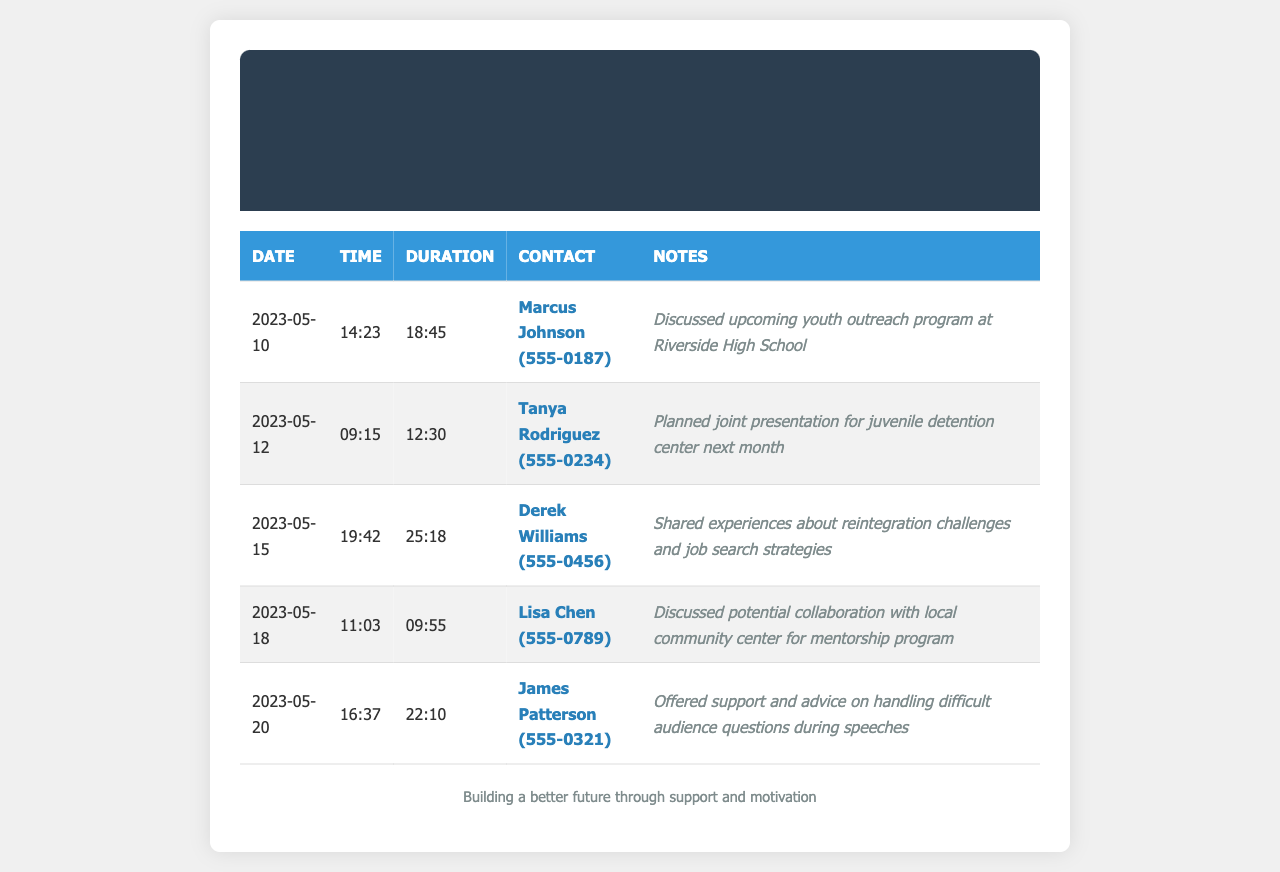What was the duration of the call with Marcus Johnson? The duration of the call is listed under the "Duration" column for Marcus Johnson on the specified date.
Answer: 18:45 What is the contact number for Tanya Rodriguez? The contact number for Tanya Rodriguez appears in the "Contact" column next to her name.
Answer: 555-0234 On what date did the call with Derek Williams take place? The date is recorded in the first column of the entry for Derek Williams.
Answer: 2023-05-15 What topic was discussed during the call with Lisa Chen? The topic is mentioned in the "Notes" column corresponding to the call with Lisa Chen.
Answer: Mentorship program How many minutes was the call with James Patterson? The duration of the call is given in the "Duration" column for James Patterson.
Answer: 22:10 Which ex-inmate talked about job search strategies? This information can be found in the "Notes" section relevant to the phone call entry.
Answer: Derek Williams What is the primary purpose of these phone records? The purpose is inferred from the overall context and structure of the document dealing with support and networking.
Answer: Support and networking How many total calls are listed in the document? Counting the entries in the table indicates the total number of calls recorded.
Answer: 5 What was the time of the call with Tanya Rodriguez? The time is recorded in the "Time" column next to Tanya Rodriguez's name.
Answer: 09:15 